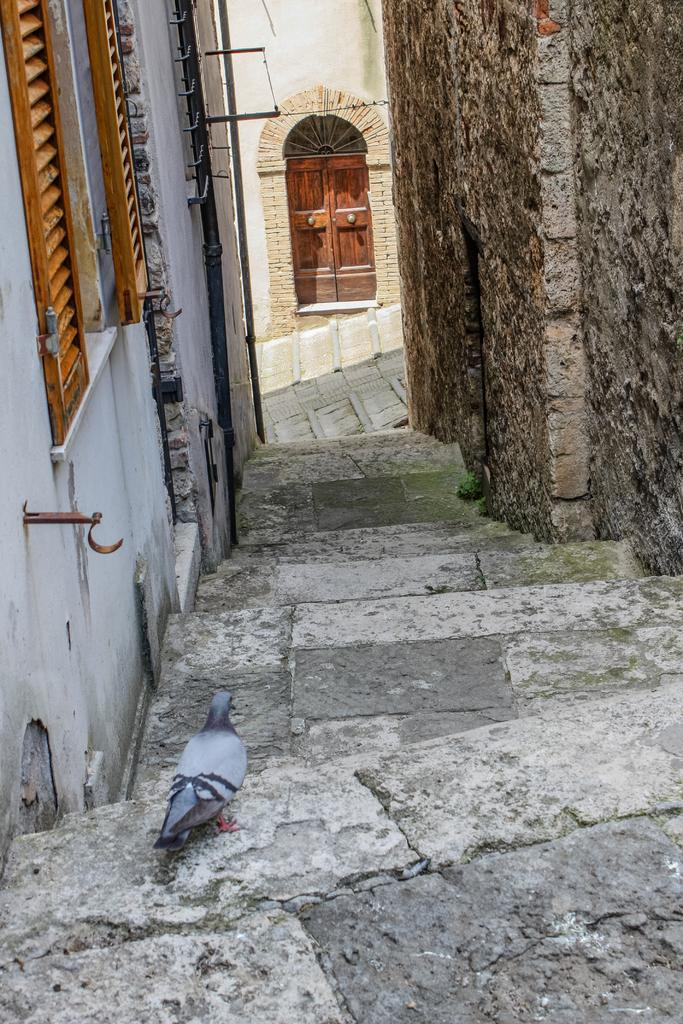What type of animal is in the image? There is a pigeon in the image. Where is the pigeon located? The pigeon is on the stairs in the image. What can be seen in the background of the image? There are buildings on both sides of the image. Is there any architectural feature visible in the image? Yes, there is a window in the image. What type of plantation can be seen in the image? There is no plantation present in the image; it features a pigeon on stairs with buildings and a window in the background. 